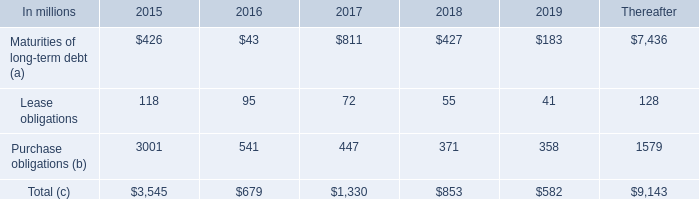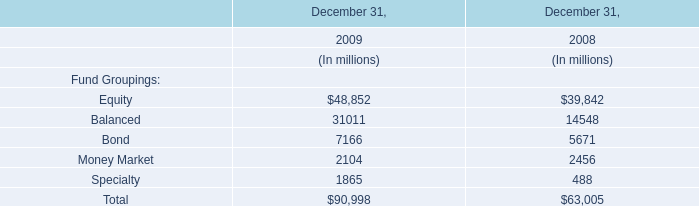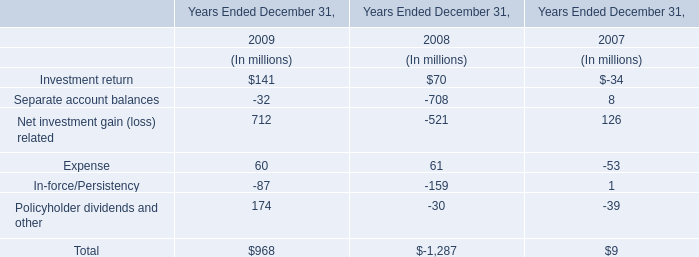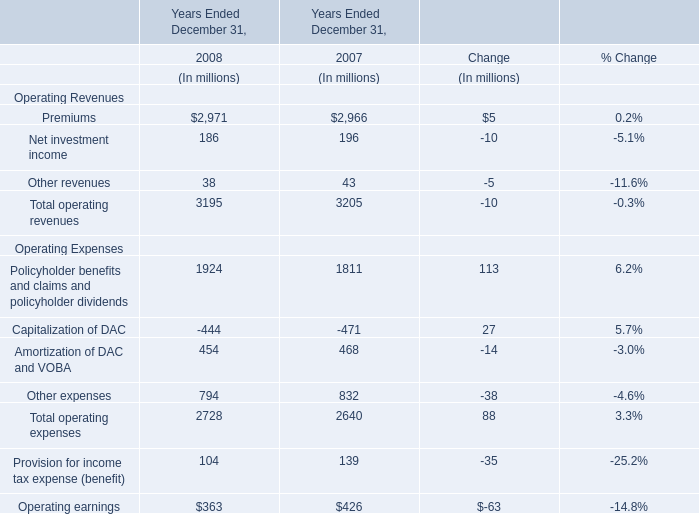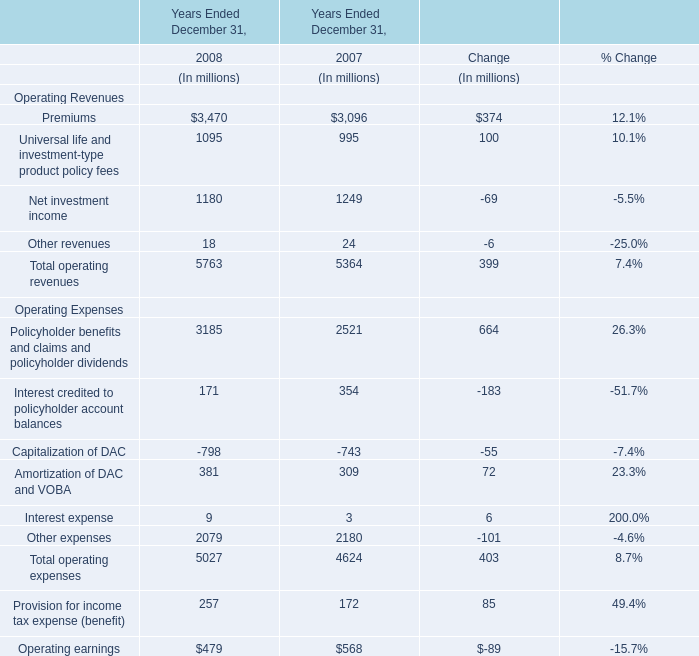Which year is Other expenses greater than 800 ? 
Answer: 2007. 